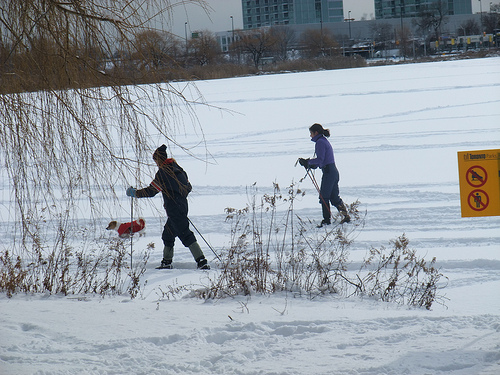What are the people in the image doing? The individuals in the image are engaging in outdoor activities in the snow. One appears to be pushing a red sled, enjoying the winter season, while the other might be walking along with a tool that could be for snow removal or ice fishing. 